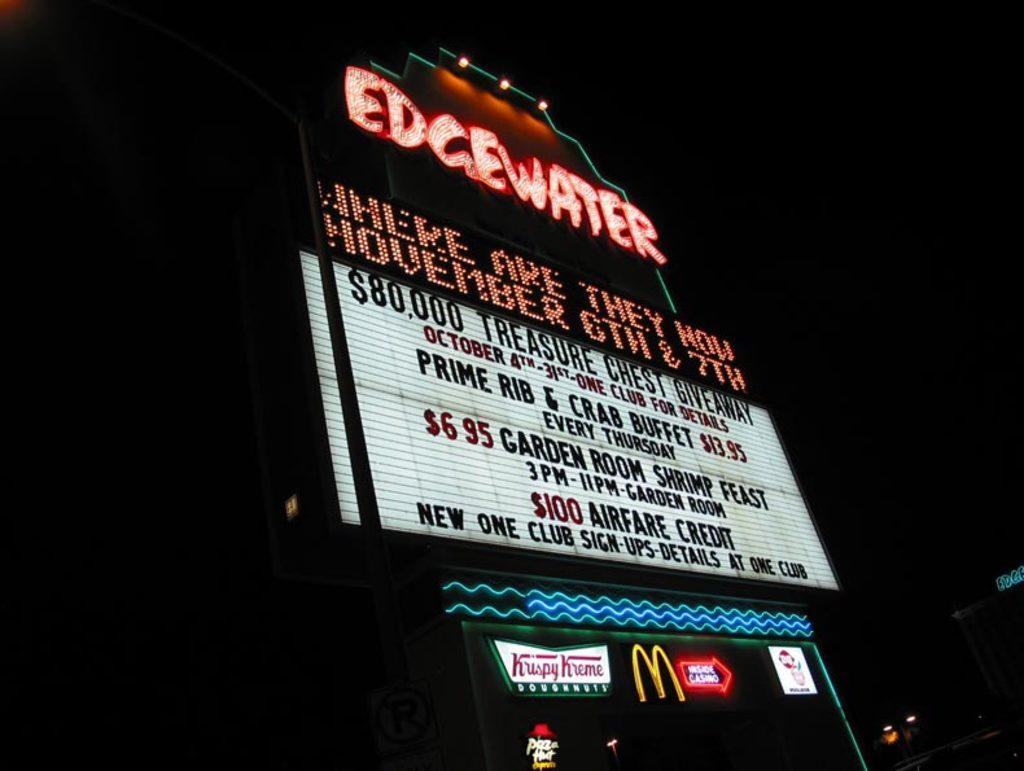<image>
Write a terse but informative summary of the picture. A sign for the Edgewater advertises an airfare credit and a shrimp feast. 